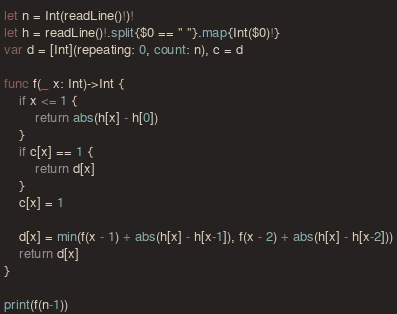<code> <loc_0><loc_0><loc_500><loc_500><_Swift_>let n = Int(readLine()!)!
let h = readLine()!.split{$0 == " "}.map{Int($0)!}
var d = [Int](repeating: 0, count: n), c = d

func f(_ x: Int)->Int {
    if x <= 1 {
        return abs(h[x] - h[0])
    }
    if c[x] == 1 {
        return d[x]
    }
    c[x] = 1

    d[x] = min(f(x - 1) + abs(h[x] - h[x-1]), f(x - 2) + abs(h[x] - h[x-2]))
    return d[x]
}

print(f(n-1))</code> 